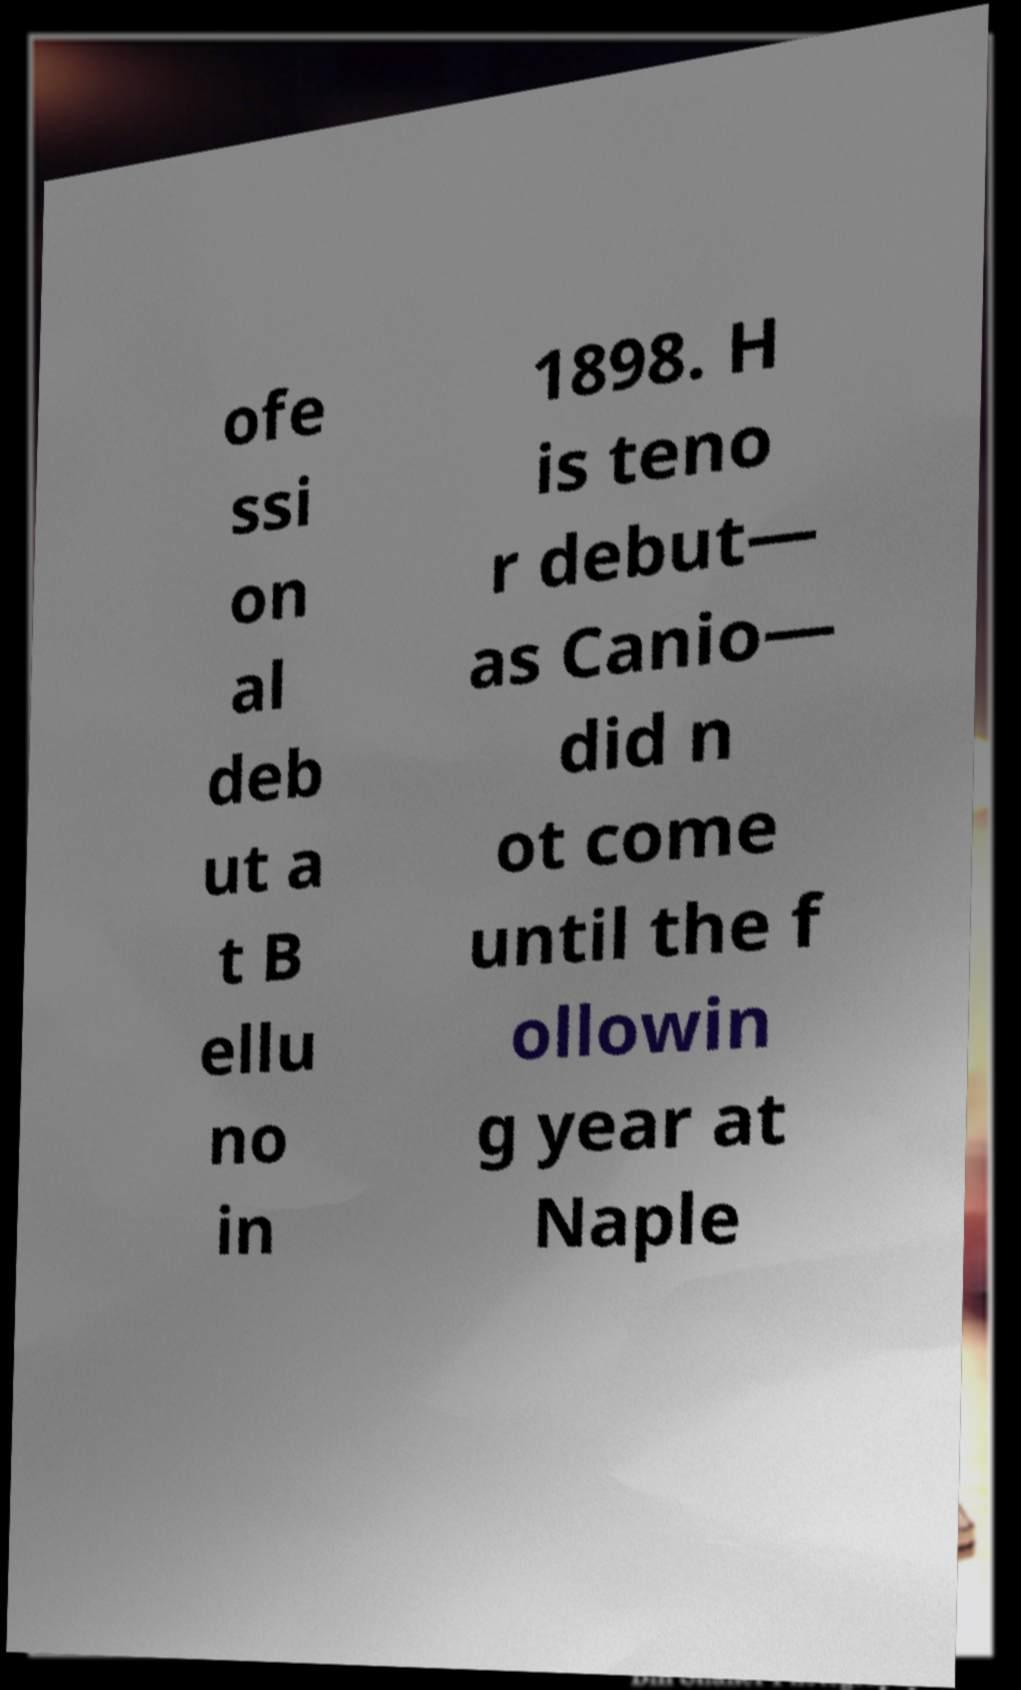There's text embedded in this image that I need extracted. Can you transcribe it verbatim? ofe ssi on al deb ut a t B ellu no in 1898. H is teno r debut— as Canio— did n ot come until the f ollowin g year at Naple 